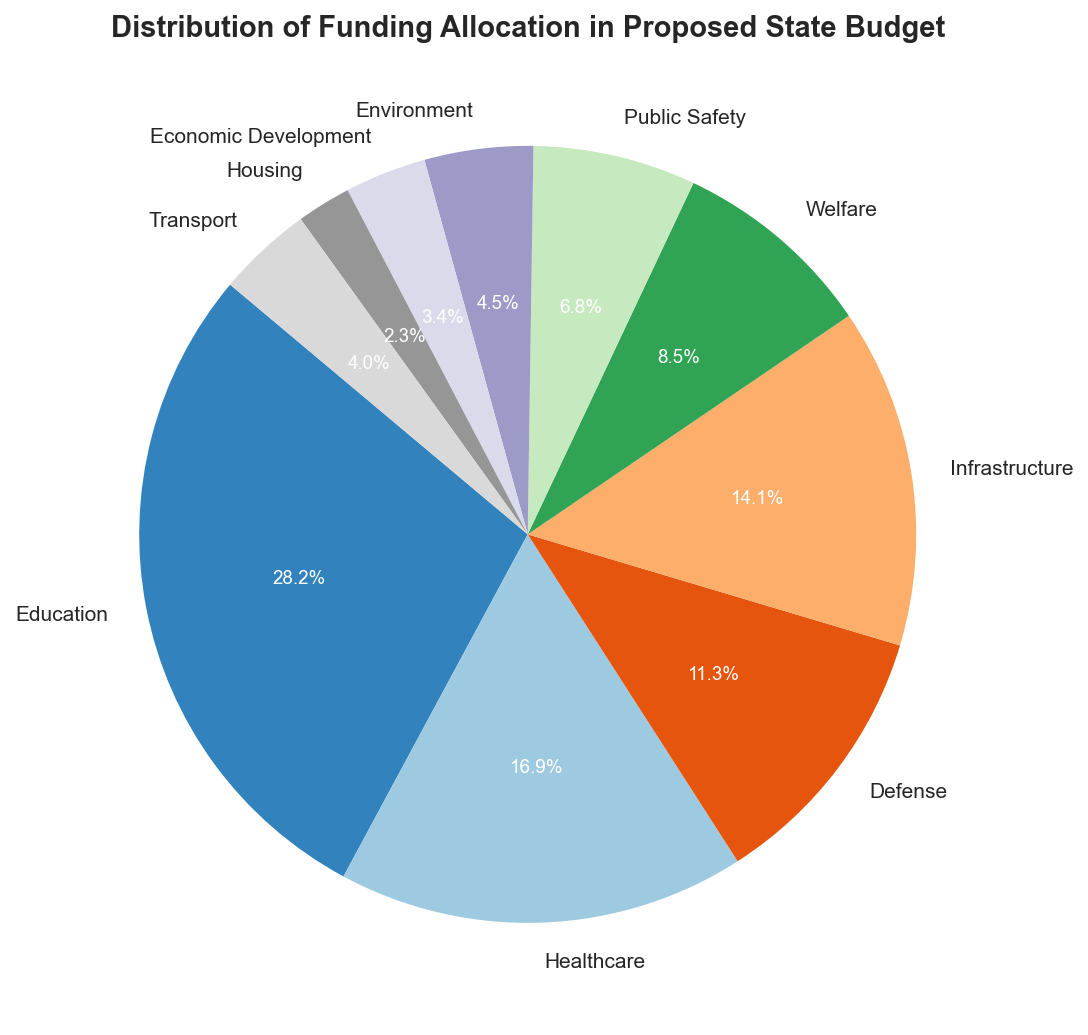Which sector has the largest allocation in the proposed budget? The largest allocation can be identified as the sector occupying the largest portion of the pie chart, which is usually the first angle counted from 0 degrees. The sector name and the percentage are clearly labeled.
Answer: Education Which two sectors combined have a total percentage higher than Healthcare? First, identify the percentage allocated to Healthcare from the pie chart. Then, look for any two sectors whose combined percentages add up to more than the Healthcare sector's allocation.
Answer: Defense and Infrastructure What percentage of the budget is allocated to sectors other than Education? Identify the percentage of the budget allocated to Education from the pie chart. Then, subtract this percentage from 100% to get the percentage allocated to all other sectors.
Answer: 55.6% Which sector receives the least amount of funding? The least funded sector corresponds to the smallest section of the pie chart, usually with a marked label and percentage.
Answer: Housing Is the funding for Environment greater than the sum of Housing and Transport? Identify the percentages for Environment, Housing, and Transport. Then, sum up the percentages for Housing and Transport and compare it with the percentage for Environment.
Answer: No How much more funding does Education receive compared to Defense? First, find the monetary values allocated to Education and Defense from the pie chart labels. Subtract the amount of Defense from the amount for Education to get the difference.
Answer: 3000 million What is the total percentage of the budget allocated to Public Safety and Welfare combined? Find and sum up the percentages allocated to Public Safety and Welfare from the pie chart.
Answer: 17.8% Which sector is represented by a greenish color section in the pie chart? By visually inspecting the pie chart, identify the sector represented by the greenish color section.
Answer: Welfare What's the difference in percentage between the allocation for Infrastructure and Economic Development? Identify the percentages for Infrastructure and Economic Development from the pie chart. Subtract the smaller percentage from the larger one to get the difference.
Answer: 15.2% 